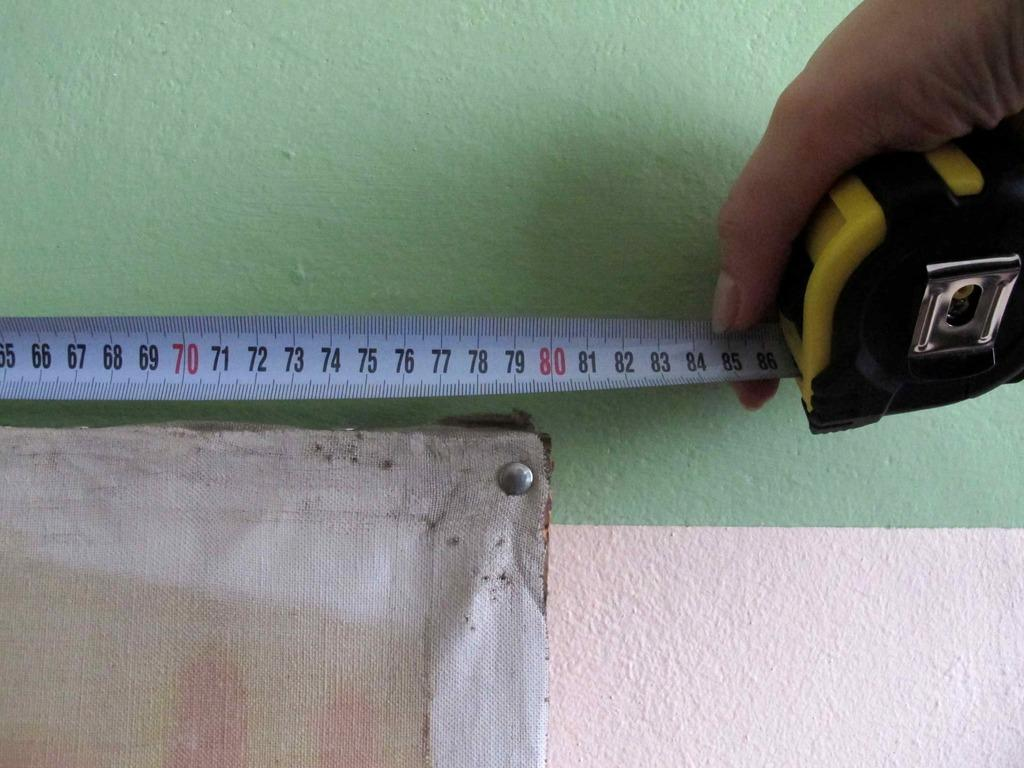<image>
Describe the image concisely. A tape measure measures the right end of an object at about 80 inches. 